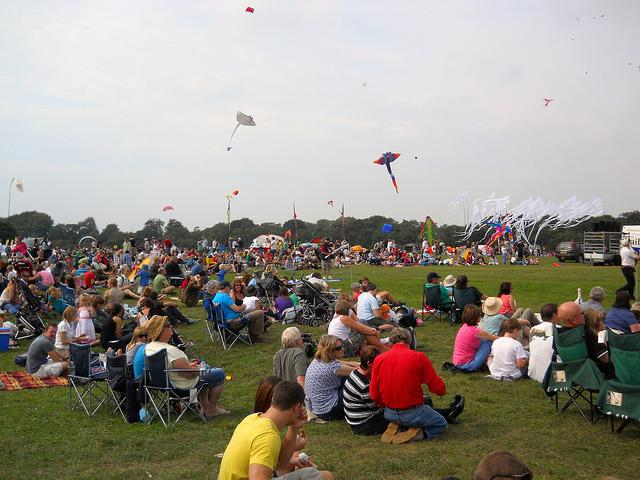What type toys unite these people today? Please explain your reasoning. toys. They are flying kites. 